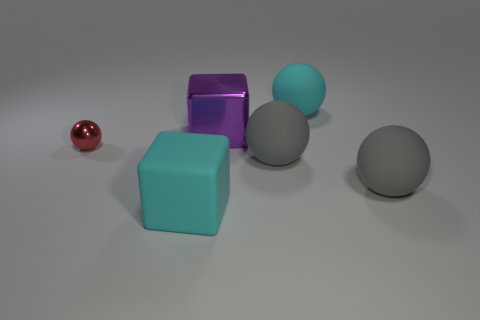What number of other objects are the same shape as the small metal thing?
Offer a terse response. 3. There is a ball to the left of the large cyan matte thing in front of the tiny red sphere; what is it made of?
Your response must be concise. Metal. How many rubber objects are cyan spheres or big cubes?
Provide a succinct answer. 2. Is there a cyan block to the right of the ball behind the small shiny sphere?
Your response must be concise. No. What number of objects are either cyan objects that are in front of the cyan ball or matte balls that are in front of the tiny object?
Keep it short and to the point. 3. Is there any other thing that has the same color as the small metallic ball?
Your response must be concise. No. The block that is in front of the small red shiny sphere on the left side of the cyan matte thing to the right of the big metallic object is what color?
Your answer should be very brief. Cyan. There is a metal thing that is on the left side of the big cyan thing that is on the left side of the metallic cube; what is its size?
Offer a very short reply. Small. The thing that is behind the matte block and left of the purple cube is made of what material?
Make the answer very short. Metal. There is a cyan rubber ball; is its size the same as the cyan thing in front of the small object?
Offer a very short reply. Yes. 